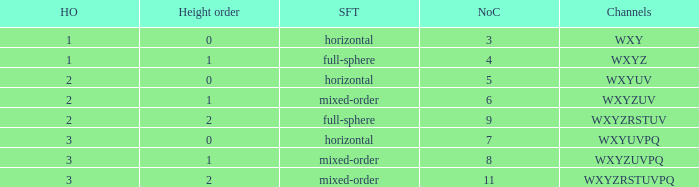If the channels is wxyzrstuvpq, what is the horizontal order? 3.0. 